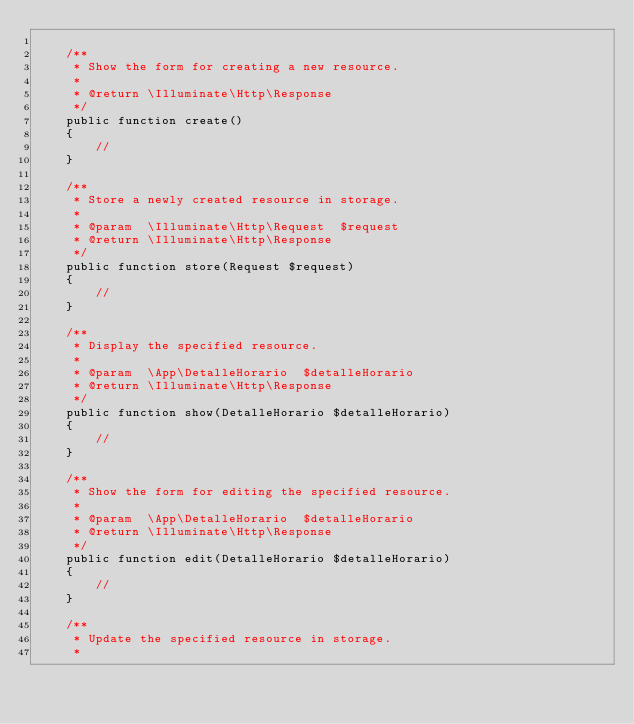<code> <loc_0><loc_0><loc_500><loc_500><_PHP_>
    /**
     * Show the form for creating a new resource.
     *
     * @return \Illuminate\Http\Response
     */
    public function create()
    {
        //
    }

    /**
     * Store a newly created resource in storage.
     *
     * @param  \Illuminate\Http\Request  $request
     * @return \Illuminate\Http\Response
     */
    public function store(Request $request)
    {
        //
    }

    /**
     * Display the specified resource.
     *
     * @param  \App\DetalleHorario  $detalleHorario
     * @return \Illuminate\Http\Response
     */
    public function show(DetalleHorario $detalleHorario)
    {
        //
    }

    /**
     * Show the form for editing the specified resource.
     *
     * @param  \App\DetalleHorario  $detalleHorario
     * @return \Illuminate\Http\Response
     */
    public function edit(DetalleHorario $detalleHorario)
    {
        //
    }

    /**
     * Update the specified resource in storage.
     *</code> 